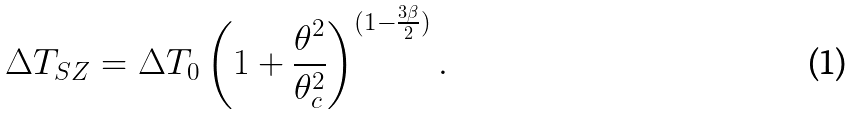Convert formula to latex. <formula><loc_0><loc_0><loc_500><loc_500>\Delta T _ { S Z } = \Delta T _ { 0 } \left ( 1 + \frac { \theta ^ { 2 } } { \theta _ { c } ^ { 2 } } \right ) ^ { ( 1 - \frac { 3 \beta } { 2 } ) } .</formula> 